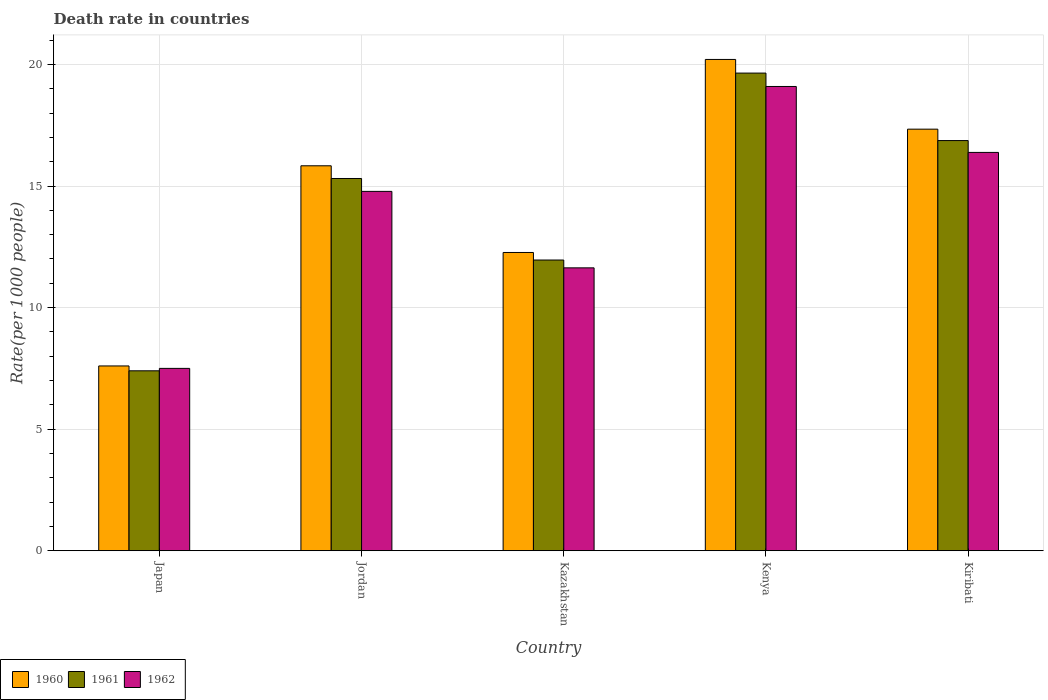How many different coloured bars are there?
Your response must be concise. 3. How many groups of bars are there?
Ensure brevity in your answer.  5. Are the number of bars per tick equal to the number of legend labels?
Make the answer very short. Yes. Are the number of bars on each tick of the X-axis equal?
Keep it short and to the point. Yes. How many bars are there on the 4th tick from the left?
Your response must be concise. 3. What is the label of the 3rd group of bars from the left?
Ensure brevity in your answer.  Kazakhstan. In how many cases, is the number of bars for a given country not equal to the number of legend labels?
Make the answer very short. 0. Across all countries, what is the maximum death rate in 1962?
Offer a terse response. 19.09. Across all countries, what is the minimum death rate in 1961?
Keep it short and to the point. 7.4. In which country was the death rate in 1960 maximum?
Provide a short and direct response. Kenya. In which country was the death rate in 1960 minimum?
Provide a short and direct response. Japan. What is the total death rate in 1962 in the graph?
Your answer should be very brief. 69.39. What is the difference between the death rate in 1960 in Jordan and that in Kenya?
Your answer should be compact. -4.37. What is the difference between the death rate in 1960 in Kenya and the death rate in 1962 in Jordan?
Offer a very short reply. 5.43. What is the average death rate in 1960 per country?
Offer a terse response. 14.65. What is the difference between the death rate of/in 1961 and death rate of/in 1960 in Kazakhstan?
Ensure brevity in your answer.  -0.31. What is the ratio of the death rate in 1960 in Jordan to that in Kazakhstan?
Keep it short and to the point. 1.29. Is the difference between the death rate in 1961 in Jordan and Kiribati greater than the difference between the death rate in 1960 in Jordan and Kiribati?
Make the answer very short. No. What is the difference between the highest and the second highest death rate in 1962?
Offer a very short reply. -2.71. What is the difference between the highest and the lowest death rate in 1962?
Give a very brief answer. 11.59. In how many countries, is the death rate in 1960 greater than the average death rate in 1960 taken over all countries?
Provide a short and direct response. 3. Is it the case that in every country, the sum of the death rate in 1961 and death rate in 1962 is greater than the death rate in 1960?
Keep it short and to the point. Yes. How many bars are there?
Your answer should be very brief. 15. What is the title of the graph?
Provide a short and direct response. Death rate in countries. What is the label or title of the Y-axis?
Your response must be concise. Rate(per 1000 people). What is the Rate(per 1000 people) of 1961 in Japan?
Ensure brevity in your answer.  7.4. What is the Rate(per 1000 people) of 1962 in Japan?
Ensure brevity in your answer.  7.5. What is the Rate(per 1000 people) of 1960 in Jordan?
Give a very brief answer. 15.83. What is the Rate(per 1000 people) in 1961 in Jordan?
Give a very brief answer. 15.31. What is the Rate(per 1000 people) in 1962 in Jordan?
Your answer should be very brief. 14.78. What is the Rate(per 1000 people) in 1960 in Kazakhstan?
Your answer should be compact. 12.27. What is the Rate(per 1000 people) in 1961 in Kazakhstan?
Your answer should be compact. 11.96. What is the Rate(per 1000 people) of 1962 in Kazakhstan?
Your answer should be very brief. 11.63. What is the Rate(per 1000 people) of 1960 in Kenya?
Your response must be concise. 20.21. What is the Rate(per 1000 people) in 1961 in Kenya?
Give a very brief answer. 19.65. What is the Rate(per 1000 people) in 1962 in Kenya?
Give a very brief answer. 19.09. What is the Rate(per 1000 people) of 1960 in Kiribati?
Offer a terse response. 17.34. What is the Rate(per 1000 people) in 1961 in Kiribati?
Make the answer very short. 16.87. What is the Rate(per 1000 people) of 1962 in Kiribati?
Offer a very short reply. 16.38. Across all countries, what is the maximum Rate(per 1000 people) in 1960?
Your response must be concise. 20.21. Across all countries, what is the maximum Rate(per 1000 people) of 1961?
Offer a terse response. 19.65. Across all countries, what is the maximum Rate(per 1000 people) in 1962?
Provide a succinct answer. 19.09. Across all countries, what is the minimum Rate(per 1000 people) in 1962?
Provide a succinct answer. 7.5. What is the total Rate(per 1000 people) of 1960 in the graph?
Your response must be concise. 73.25. What is the total Rate(per 1000 people) of 1961 in the graph?
Keep it short and to the point. 71.18. What is the total Rate(per 1000 people) of 1962 in the graph?
Give a very brief answer. 69.39. What is the difference between the Rate(per 1000 people) in 1960 in Japan and that in Jordan?
Offer a very short reply. -8.23. What is the difference between the Rate(per 1000 people) in 1961 in Japan and that in Jordan?
Offer a terse response. -7.91. What is the difference between the Rate(per 1000 people) in 1962 in Japan and that in Jordan?
Make the answer very short. -7.28. What is the difference between the Rate(per 1000 people) of 1960 in Japan and that in Kazakhstan?
Provide a succinct answer. -4.67. What is the difference between the Rate(per 1000 people) of 1961 in Japan and that in Kazakhstan?
Offer a very short reply. -4.56. What is the difference between the Rate(per 1000 people) in 1962 in Japan and that in Kazakhstan?
Your response must be concise. -4.13. What is the difference between the Rate(per 1000 people) in 1960 in Japan and that in Kenya?
Offer a very short reply. -12.61. What is the difference between the Rate(per 1000 people) of 1961 in Japan and that in Kenya?
Offer a terse response. -12.25. What is the difference between the Rate(per 1000 people) of 1962 in Japan and that in Kenya?
Your answer should be very brief. -11.6. What is the difference between the Rate(per 1000 people) of 1960 in Japan and that in Kiribati?
Offer a terse response. -9.74. What is the difference between the Rate(per 1000 people) of 1961 in Japan and that in Kiribati?
Make the answer very short. -9.47. What is the difference between the Rate(per 1000 people) of 1962 in Japan and that in Kiribati?
Make the answer very short. -8.88. What is the difference between the Rate(per 1000 people) of 1960 in Jordan and that in Kazakhstan?
Your answer should be very brief. 3.57. What is the difference between the Rate(per 1000 people) of 1961 in Jordan and that in Kazakhstan?
Your answer should be very brief. 3.35. What is the difference between the Rate(per 1000 people) in 1962 in Jordan and that in Kazakhstan?
Ensure brevity in your answer.  3.15. What is the difference between the Rate(per 1000 people) in 1960 in Jordan and that in Kenya?
Provide a short and direct response. -4.37. What is the difference between the Rate(per 1000 people) of 1961 in Jordan and that in Kenya?
Your response must be concise. -4.34. What is the difference between the Rate(per 1000 people) in 1962 in Jordan and that in Kenya?
Offer a terse response. -4.32. What is the difference between the Rate(per 1000 people) of 1960 in Jordan and that in Kiribati?
Offer a terse response. -1.51. What is the difference between the Rate(per 1000 people) in 1961 in Jordan and that in Kiribati?
Your response must be concise. -1.56. What is the difference between the Rate(per 1000 people) in 1962 in Jordan and that in Kiribati?
Your answer should be compact. -1.6. What is the difference between the Rate(per 1000 people) of 1960 in Kazakhstan and that in Kenya?
Keep it short and to the point. -7.94. What is the difference between the Rate(per 1000 people) of 1961 in Kazakhstan and that in Kenya?
Your answer should be compact. -7.69. What is the difference between the Rate(per 1000 people) of 1962 in Kazakhstan and that in Kenya?
Your response must be concise. -7.46. What is the difference between the Rate(per 1000 people) of 1960 in Kazakhstan and that in Kiribati?
Give a very brief answer. -5.07. What is the difference between the Rate(per 1000 people) of 1961 in Kazakhstan and that in Kiribati?
Provide a short and direct response. -4.91. What is the difference between the Rate(per 1000 people) in 1962 in Kazakhstan and that in Kiribati?
Provide a succinct answer. -4.75. What is the difference between the Rate(per 1000 people) in 1960 in Kenya and that in Kiribati?
Make the answer very short. 2.87. What is the difference between the Rate(per 1000 people) in 1961 in Kenya and that in Kiribati?
Your response must be concise. 2.78. What is the difference between the Rate(per 1000 people) in 1962 in Kenya and that in Kiribati?
Provide a short and direct response. 2.71. What is the difference between the Rate(per 1000 people) of 1960 in Japan and the Rate(per 1000 people) of 1961 in Jordan?
Provide a succinct answer. -7.71. What is the difference between the Rate(per 1000 people) of 1960 in Japan and the Rate(per 1000 people) of 1962 in Jordan?
Provide a short and direct response. -7.18. What is the difference between the Rate(per 1000 people) of 1961 in Japan and the Rate(per 1000 people) of 1962 in Jordan?
Provide a succinct answer. -7.38. What is the difference between the Rate(per 1000 people) in 1960 in Japan and the Rate(per 1000 people) in 1961 in Kazakhstan?
Offer a very short reply. -4.36. What is the difference between the Rate(per 1000 people) in 1960 in Japan and the Rate(per 1000 people) in 1962 in Kazakhstan?
Provide a short and direct response. -4.04. What is the difference between the Rate(per 1000 people) of 1961 in Japan and the Rate(per 1000 people) of 1962 in Kazakhstan?
Your answer should be compact. -4.24. What is the difference between the Rate(per 1000 people) in 1960 in Japan and the Rate(per 1000 people) in 1961 in Kenya?
Provide a succinct answer. -12.05. What is the difference between the Rate(per 1000 people) of 1960 in Japan and the Rate(per 1000 people) of 1962 in Kenya?
Your answer should be very brief. -11.49. What is the difference between the Rate(per 1000 people) of 1961 in Japan and the Rate(per 1000 people) of 1962 in Kenya?
Your answer should be very brief. -11.7. What is the difference between the Rate(per 1000 people) of 1960 in Japan and the Rate(per 1000 people) of 1961 in Kiribati?
Make the answer very short. -9.27. What is the difference between the Rate(per 1000 people) of 1960 in Japan and the Rate(per 1000 people) of 1962 in Kiribati?
Your response must be concise. -8.78. What is the difference between the Rate(per 1000 people) of 1961 in Japan and the Rate(per 1000 people) of 1962 in Kiribati?
Your answer should be very brief. -8.98. What is the difference between the Rate(per 1000 people) of 1960 in Jordan and the Rate(per 1000 people) of 1961 in Kazakhstan?
Keep it short and to the point. 3.88. What is the difference between the Rate(per 1000 people) in 1960 in Jordan and the Rate(per 1000 people) in 1962 in Kazakhstan?
Provide a short and direct response. 4.2. What is the difference between the Rate(per 1000 people) in 1961 in Jordan and the Rate(per 1000 people) in 1962 in Kazakhstan?
Ensure brevity in your answer.  3.67. What is the difference between the Rate(per 1000 people) of 1960 in Jordan and the Rate(per 1000 people) of 1961 in Kenya?
Provide a succinct answer. -3.81. What is the difference between the Rate(per 1000 people) in 1960 in Jordan and the Rate(per 1000 people) in 1962 in Kenya?
Provide a short and direct response. -3.26. What is the difference between the Rate(per 1000 people) in 1961 in Jordan and the Rate(per 1000 people) in 1962 in Kenya?
Give a very brief answer. -3.79. What is the difference between the Rate(per 1000 people) of 1960 in Jordan and the Rate(per 1000 people) of 1961 in Kiribati?
Make the answer very short. -1.04. What is the difference between the Rate(per 1000 people) in 1960 in Jordan and the Rate(per 1000 people) in 1962 in Kiribati?
Make the answer very short. -0.55. What is the difference between the Rate(per 1000 people) in 1961 in Jordan and the Rate(per 1000 people) in 1962 in Kiribati?
Provide a short and direct response. -1.07. What is the difference between the Rate(per 1000 people) of 1960 in Kazakhstan and the Rate(per 1000 people) of 1961 in Kenya?
Your response must be concise. -7.38. What is the difference between the Rate(per 1000 people) in 1960 in Kazakhstan and the Rate(per 1000 people) in 1962 in Kenya?
Your answer should be compact. -6.83. What is the difference between the Rate(per 1000 people) of 1961 in Kazakhstan and the Rate(per 1000 people) of 1962 in Kenya?
Ensure brevity in your answer.  -7.14. What is the difference between the Rate(per 1000 people) in 1960 in Kazakhstan and the Rate(per 1000 people) in 1961 in Kiribati?
Your answer should be very brief. -4.6. What is the difference between the Rate(per 1000 people) in 1960 in Kazakhstan and the Rate(per 1000 people) in 1962 in Kiribati?
Offer a very short reply. -4.12. What is the difference between the Rate(per 1000 people) of 1961 in Kazakhstan and the Rate(per 1000 people) of 1962 in Kiribati?
Provide a short and direct response. -4.43. What is the difference between the Rate(per 1000 people) in 1960 in Kenya and the Rate(per 1000 people) in 1961 in Kiribati?
Provide a short and direct response. 3.34. What is the difference between the Rate(per 1000 people) in 1960 in Kenya and the Rate(per 1000 people) in 1962 in Kiribati?
Give a very brief answer. 3.82. What is the difference between the Rate(per 1000 people) in 1961 in Kenya and the Rate(per 1000 people) in 1962 in Kiribati?
Ensure brevity in your answer.  3.26. What is the average Rate(per 1000 people) in 1960 per country?
Ensure brevity in your answer.  14.65. What is the average Rate(per 1000 people) in 1961 per country?
Offer a very short reply. 14.24. What is the average Rate(per 1000 people) in 1962 per country?
Make the answer very short. 13.88. What is the difference between the Rate(per 1000 people) of 1960 and Rate(per 1000 people) of 1962 in Japan?
Offer a terse response. 0.1. What is the difference between the Rate(per 1000 people) of 1960 and Rate(per 1000 people) of 1961 in Jordan?
Ensure brevity in your answer.  0.52. What is the difference between the Rate(per 1000 people) of 1960 and Rate(per 1000 people) of 1962 in Jordan?
Provide a succinct answer. 1.05. What is the difference between the Rate(per 1000 people) in 1961 and Rate(per 1000 people) in 1962 in Jordan?
Provide a succinct answer. 0.53. What is the difference between the Rate(per 1000 people) of 1960 and Rate(per 1000 people) of 1961 in Kazakhstan?
Provide a short and direct response. 0.31. What is the difference between the Rate(per 1000 people) of 1960 and Rate(per 1000 people) of 1962 in Kazakhstan?
Offer a very short reply. 0.63. What is the difference between the Rate(per 1000 people) of 1961 and Rate(per 1000 people) of 1962 in Kazakhstan?
Keep it short and to the point. 0.32. What is the difference between the Rate(per 1000 people) of 1960 and Rate(per 1000 people) of 1961 in Kenya?
Offer a very short reply. 0.56. What is the difference between the Rate(per 1000 people) in 1960 and Rate(per 1000 people) in 1962 in Kenya?
Provide a succinct answer. 1.11. What is the difference between the Rate(per 1000 people) in 1961 and Rate(per 1000 people) in 1962 in Kenya?
Make the answer very short. 0.55. What is the difference between the Rate(per 1000 people) in 1960 and Rate(per 1000 people) in 1961 in Kiribati?
Provide a short and direct response. 0.47. What is the difference between the Rate(per 1000 people) in 1960 and Rate(per 1000 people) in 1962 in Kiribati?
Offer a very short reply. 0.96. What is the difference between the Rate(per 1000 people) of 1961 and Rate(per 1000 people) of 1962 in Kiribati?
Offer a terse response. 0.49. What is the ratio of the Rate(per 1000 people) of 1960 in Japan to that in Jordan?
Offer a very short reply. 0.48. What is the ratio of the Rate(per 1000 people) of 1961 in Japan to that in Jordan?
Provide a succinct answer. 0.48. What is the ratio of the Rate(per 1000 people) of 1962 in Japan to that in Jordan?
Offer a very short reply. 0.51. What is the ratio of the Rate(per 1000 people) in 1960 in Japan to that in Kazakhstan?
Offer a very short reply. 0.62. What is the ratio of the Rate(per 1000 people) in 1961 in Japan to that in Kazakhstan?
Your answer should be compact. 0.62. What is the ratio of the Rate(per 1000 people) of 1962 in Japan to that in Kazakhstan?
Give a very brief answer. 0.64. What is the ratio of the Rate(per 1000 people) of 1960 in Japan to that in Kenya?
Give a very brief answer. 0.38. What is the ratio of the Rate(per 1000 people) of 1961 in Japan to that in Kenya?
Provide a short and direct response. 0.38. What is the ratio of the Rate(per 1000 people) of 1962 in Japan to that in Kenya?
Offer a very short reply. 0.39. What is the ratio of the Rate(per 1000 people) of 1960 in Japan to that in Kiribati?
Provide a succinct answer. 0.44. What is the ratio of the Rate(per 1000 people) of 1961 in Japan to that in Kiribati?
Your response must be concise. 0.44. What is the ratio of the Rate(per 1000 people) in 1962 in Japan to that in Kiribati?
Make the answer very short. 0.46. What is the ratio of the Rate(per 1000 people) of 1960 in Jordan to that in Kazakhstan?
Provide a short and direct response. 1.29. What is the ratio of the Rate(per 1000 people) of 1961 in Jordan to that in Kazakhstan?
Provide a succinct answer. 1.28. What is the ratio of the Rate(per 1000 people) of 1962 in Jordan to that in Kazakhstan?
Your response must be concise. 1.27. What is the ratio of the Rate(per 1000 people) in 1960 in Jordan to that in Kenya?
Your answer should be compact. 0.78. What is the ratio of the Rate(per 1000 people) in 1961 in Jordan to that in Kenya?
Offer a terse response. 0.78. What is the ratio of the Rate(per 1000 people) of 1962 in Jordan to that in Kenya?
Provide a short and direct response. 0.77. What is the ratio of the Rate(per 1000 people) of 1960 in Jordan to that in Kiribati?
Offer a very short reply. 0.91. What is the ratio of the Rate(per 1000 people) of 1961 in Jordan to that in Kiribati?
Your answer should be very brief. 0.91. What is the ratio of the Rate(per 1000 people) in 1962 in Jordan to that in Kiribati?
Offer a terse response. 0.9. What is the ratio of the Rate(per 1000 people) of 1960 in Kazakhstan to that in Kenya?
Keep it short and to the point. 0.61. What is the ratio of the Rate(per 1000 people) in 1961 in Kazakhstan to that in Kenya?
Offer a very short reply. 0.61. What is the ratio of the Rate(per 1000 people) in 1962 in Kazakhstan to that in Kenya?
Offer a terse response. 0.61. What is the ratio of the Rate(per 1000 people) of 1960 in Kazakhstan to that in Kiribati?
Your answer should be very brief. 0.71. What is the ratio of the Rate(per 1000 people) of 1961 in Kazakhstan to that in Kiribati?
Provide a short and direct response. 0.71. What is the ratio of the Rate(per 1000 people) of 1962 in Kazakhstan to that in Kiribati?
Keep it short and to the point. 0.71. What is the ratio of the Rate(per 1000 people) in 1960 in Kenya to that in Kiribati?
Make the answer very short. 1.17. What is the ratio of the Rate(per 1000 people) of 1961 in Kenya to that in Kiribati?
Your answer should be compact. 1.16. What is the ratio of the Rate(per 1000 people) in 1962 in Kenya to that in Kiribati?
Ensure brevity in your answer.  1.17. What is the difference between the highest and the second highest Rate(per 1000 people) in 1960?
Provide a short and direct response. 2.87. What is the difference between the highest and the second highest Rate(per 1000 people) in 1961?
Make the answer very short. 2.78. What is the difference between the highest and the second highest Rate(per 1000 people) in 1962?
Make the answer very short. 2.71. What is the difference between the highest and the lowest Rate(per 1000 people) of 1960?
Ensure brevity in your answer.  12.61. What is the difference between the highest and the lowest Rate(per 1000 people) in 1961?
Your response must be concise. 12.25. What is the difference between the highest and the lowest Rate(per 1000 people) in 1962?
Provide a short and direct response. 11.6. 